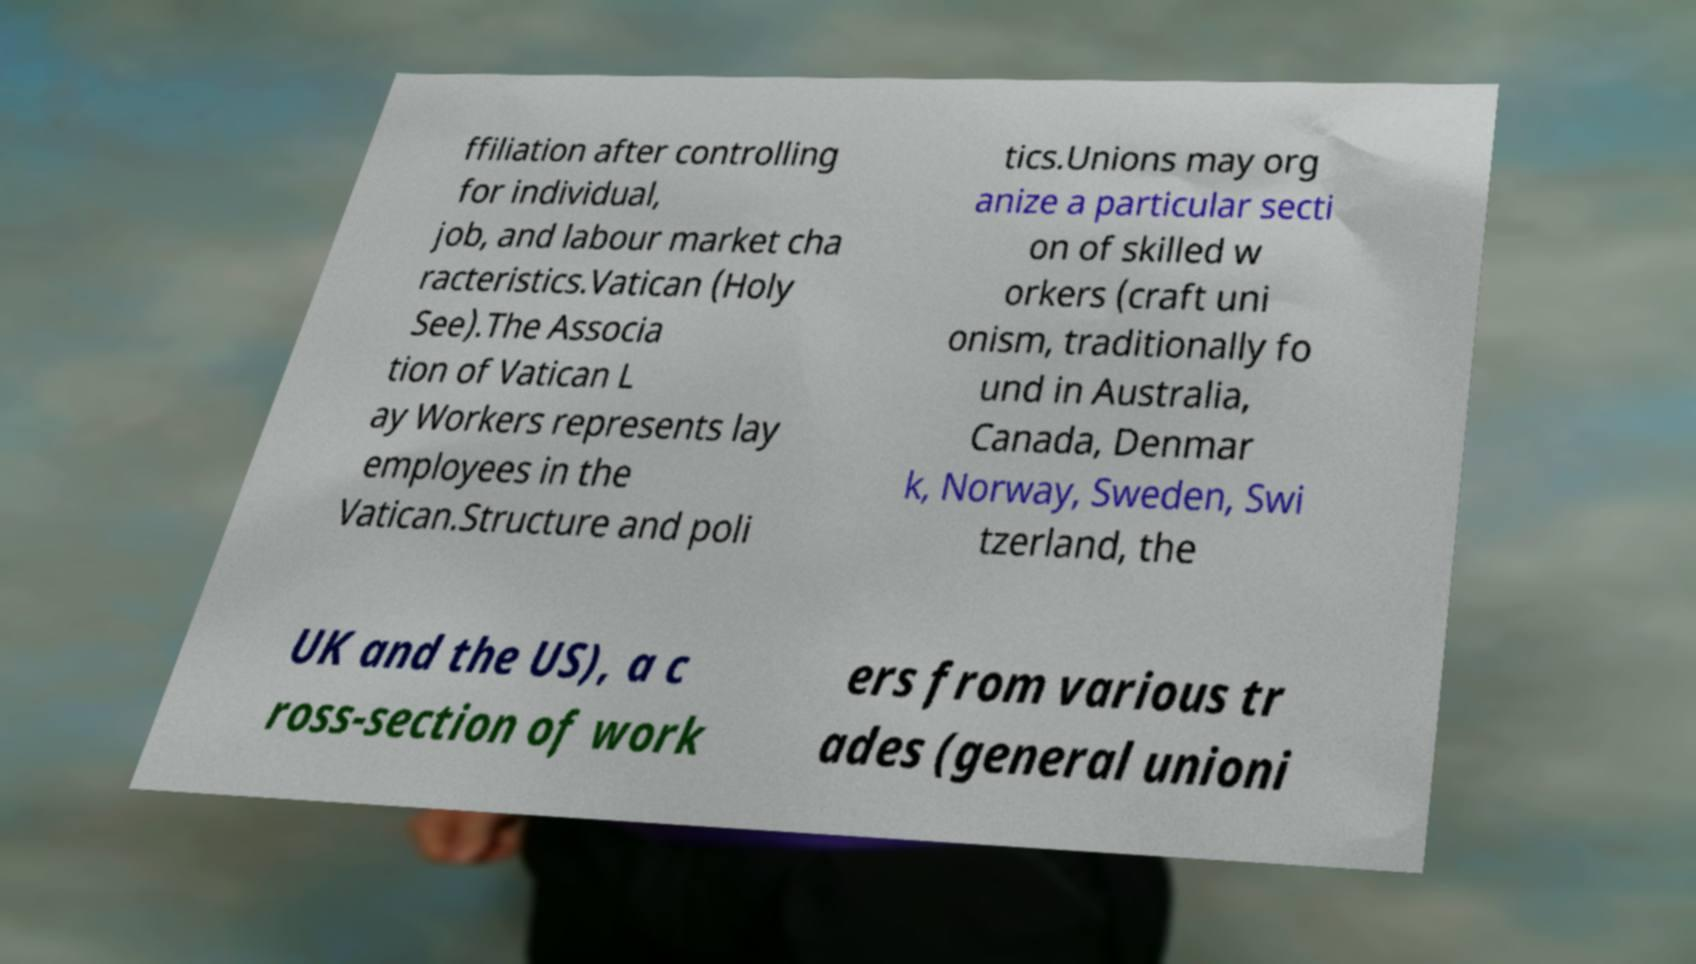There's text embedded in this image that I need extracted. Can you transcribe it verbatim? ffiliation after controlling for individual, job, and labour market cha racteristics.Vatican (Holy See).The Associa tion of Vatican L ay Workers represents lay employees in the Vatican.Structure and poli tics.Unions may org anize a particular secti on of skilled w orkers (craft uni onism, traditionally fo und in Australia, Canada, Denmar k, Norway, Sweden, Swi tzerland, the UK and the US), a c ross-section of work ers from various tr ades (general unioni 